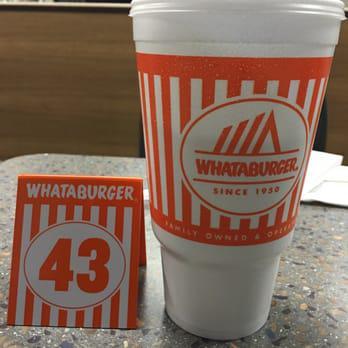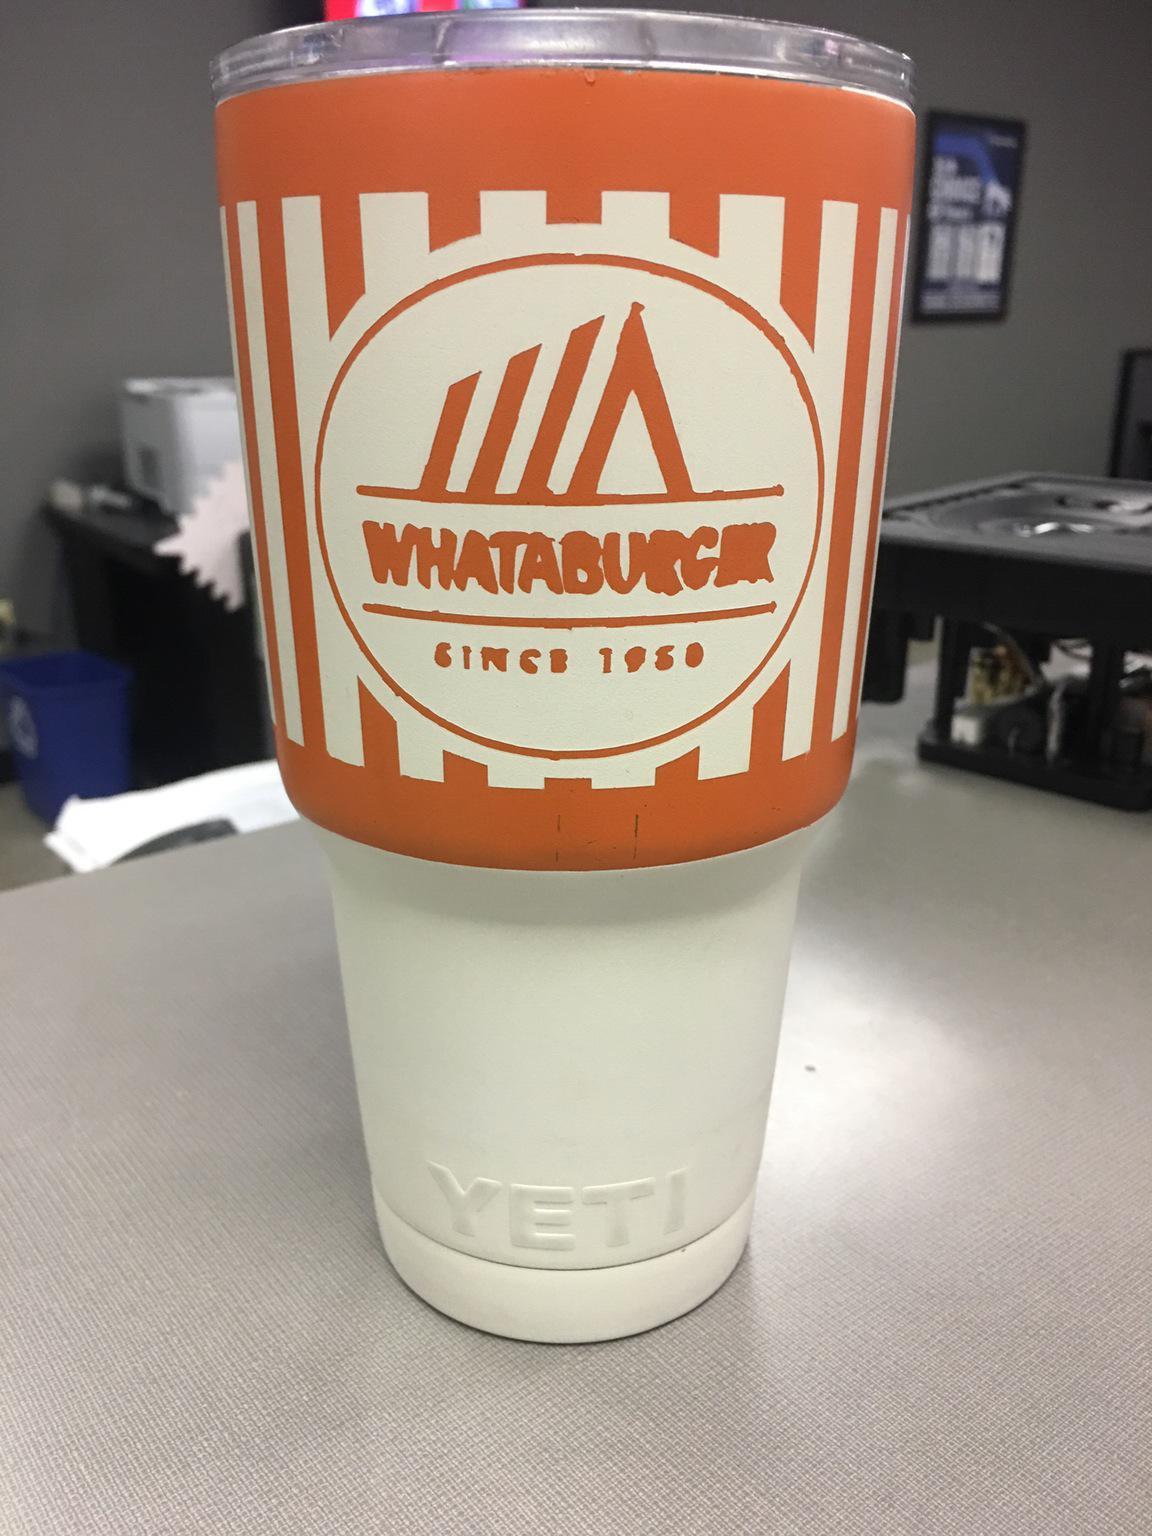The first image is the image on the left, the second image is the image on the right. Examine the images to the left and right. Is the description "The right image shows a """"Whataburger"""" cup sitting on a surface." accurate? Answer yes or no. Yes. The first image is the image on the left, the second image is the image on the right. Considering the images on both sides, is "There are two large orange and white cups sitting directly on a table." valid? Answer yes or no. Yes. 